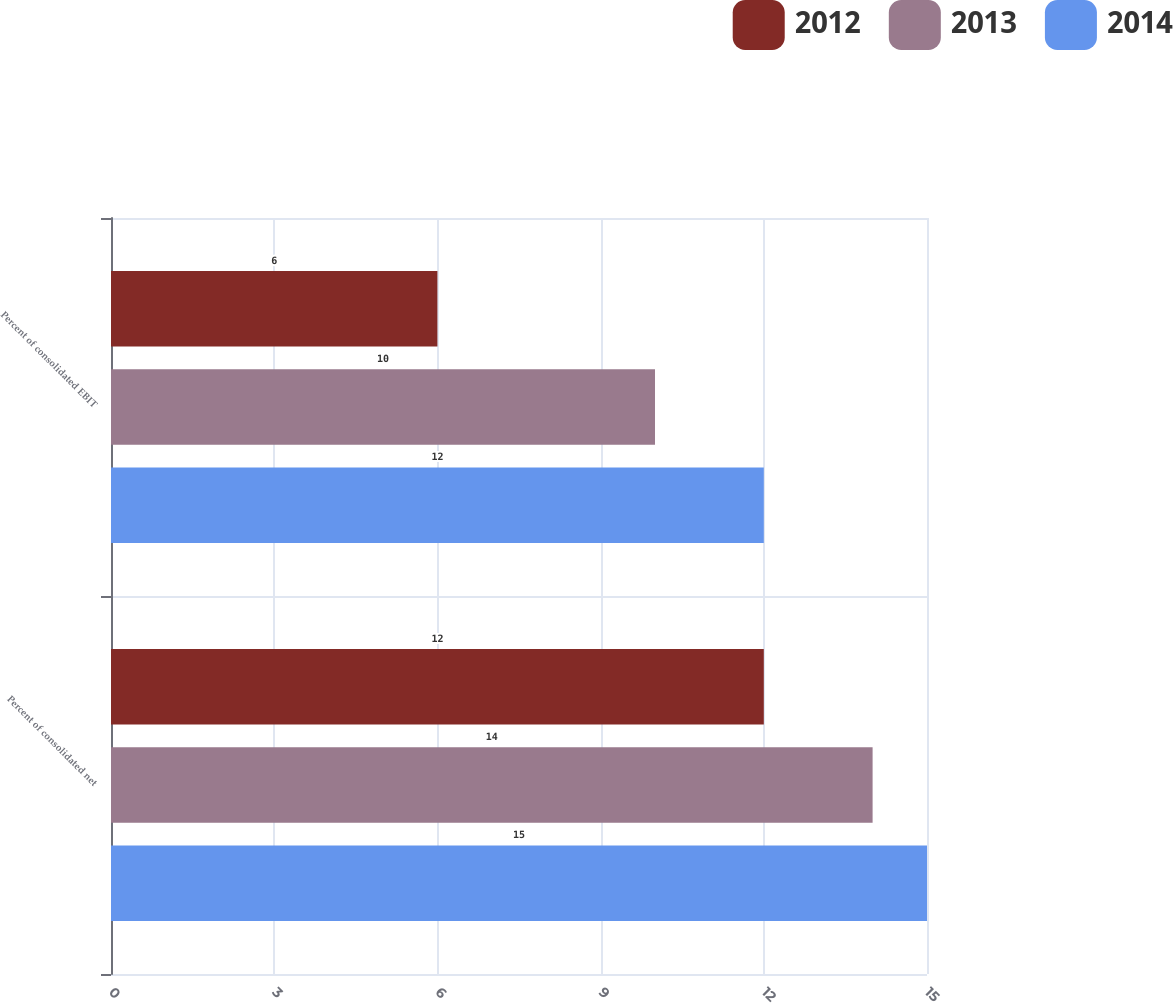Convert chart. <chart><loc_0><loc_0><loc_500><loc_500><stacked_bar_chart><ecel><fcel>Percent of consolidated net<fcel>Percent of consolidated EBIT<nl><fcel>2012<fcel>12<fcel>6<nl><fcel>2013<fcel>14<fcel>10<nl><fcel>2014<fcel>15<fcel>12<nl></chart> 